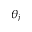Convert formula to latex. <formula><loc_0><loc_0><loc_500><loc_500>\theta _ { j }</formula> 